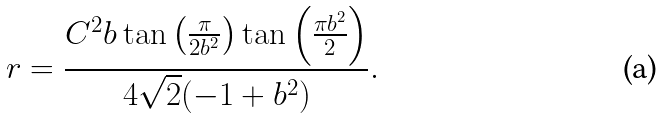<formula> <loc_0><loc_0><loc_500><loc_500>r = \frac { C ^ { 2 } b \tan \left ( \frac { \pi } { 2 b ^ { 2 } } \right ) \tan \left ( \frac { \pi b ^ { 2 } } { 2 } \right ) } { 4 \sqrt { 2 } ( - 1 + b ^ { 2 } ) } .</formula> 